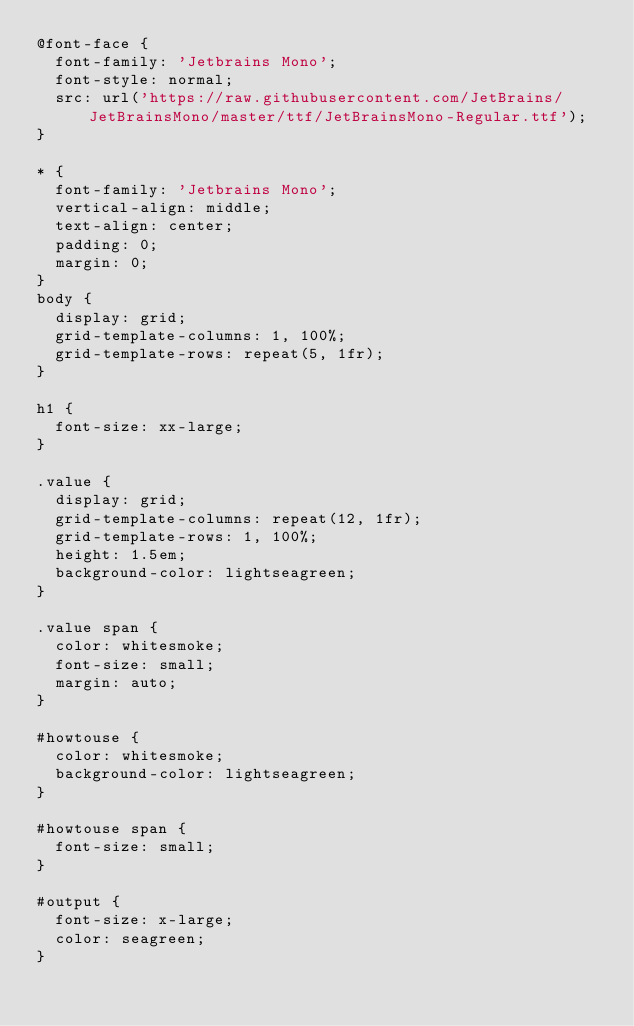Convert code to text. <code><loc_0><loc_0><loc_500><loc_500><_CSS_>@font-face {
	font-family: 'Jetbrains Mono';
	font-style: normal;
	src: url('https://raw.githubusercontent.com/JetBrains/JetBrainsMono/master/ttf/JetBrainsMono-Regular.ttf');
}

* {
	font-family: 'Jetbrains Mono';
	vertical-align: middle;
	text-align: center;
	padding: 0;
	margin: 0;
}
body {
	display: grid;
	grid-template-columns: 1, 100%;
	grid-template-rows: repeat(5, 1fr);
}

h1 {
	font-size: xx-large;
}

.value {
	display: grid;
	grid-template-columns: repeat(12, 1fr);
	grid-template-rows: 1, 100%;
	height: 1.5em;
	background-color: lightseagreen;
}

.value span {
	color: whitesmoke;
	font-size: small;
	margin: auto;
}

#howtouse {
	color: whitesmoke;
	background-color: lightseagreen;
}

#howtouse span {
	font-size: small;
}

#output {
	font-size: x-large;
	color: seagreen;
}
</code> 